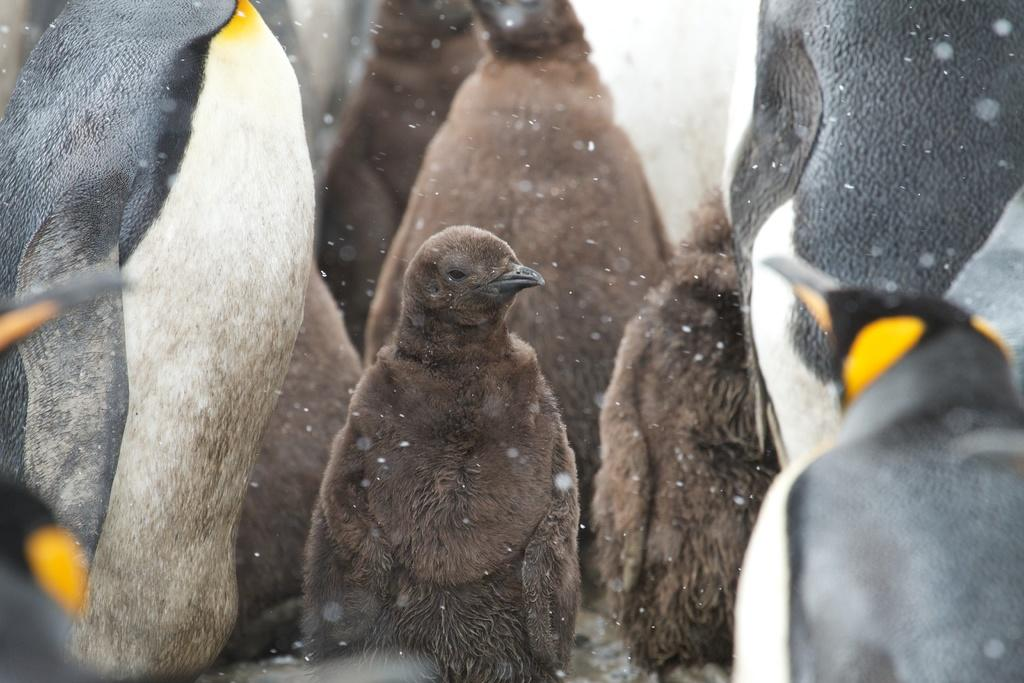What is happening in the image? Snow is falling in the image. What animals are present in the image? There are penguins in the image. What is the plot of the story unfolding in the image? There is no story or plot depicted in the image; it simply shows snow falling and penguins. What type of machine can be seen in the image? There is no machine present in the image; it features snow and penguins. 